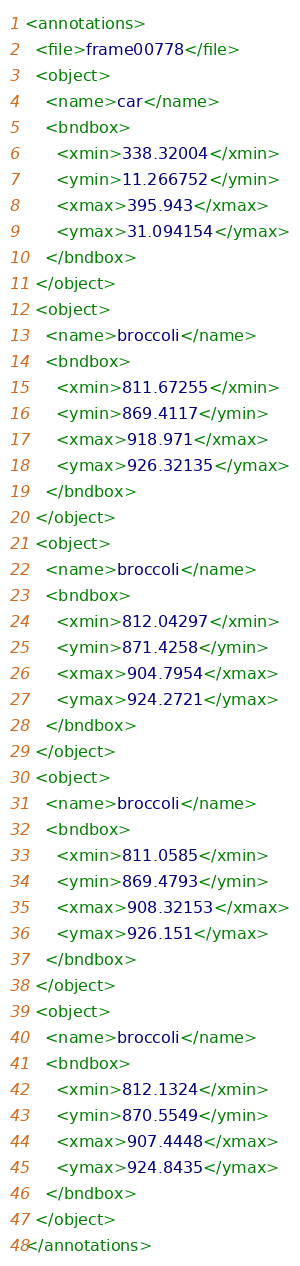<code> <loc_0><loc_0><loc_500><loc_500><_XML_><annotations>
  <file>frame00778</file>
  <object>
    <name>car</name>
    <bndbox>
      <xmin>338.32004</xmin>
      <ymin>11.266752</ymin>
      <xmax>395.943</xmax>
      <ymax>31.094154</ymax>
    </bndbox>
  </object>
  <object>
    <name>broccoli</name>
    <bndbox>
      <xmin>811.67255</xmin>
      <ymin>869.4117</ymin>
      <xmax>918.971</xmax>
      <ymax>926.32135</ymax>
    </bndbox>
  </object>
  <object>
    <name>broccoli</name>
    <bndbox>
      <xmin>812.04297</xmin>
      <ymin>871.4258</ymin>
      <xmax>904.7954</xmax>
      <ymax>924.2721</ymax>
    </bndbox>
  </object>
  <object>
    <name>broccoli</name>
    <bndbox>
      <xmin>811.0585</xmin>
      <ymin>869.4793</ymin>
      <xmax>908.32153</xmax>
      <ymax>926.151</ymax>
    </bndbox>
  </object>
  <object>
    <name>broccoli</name>
    <bndbox>
      <xmin>812.1324</xmin>
      <ymin>870.5549</ymin>
      <xmax>907.4448</xmax>
      <ymax>924.8435</ymax>
    </bndbox>
  </object>
</annotations>
</code> 